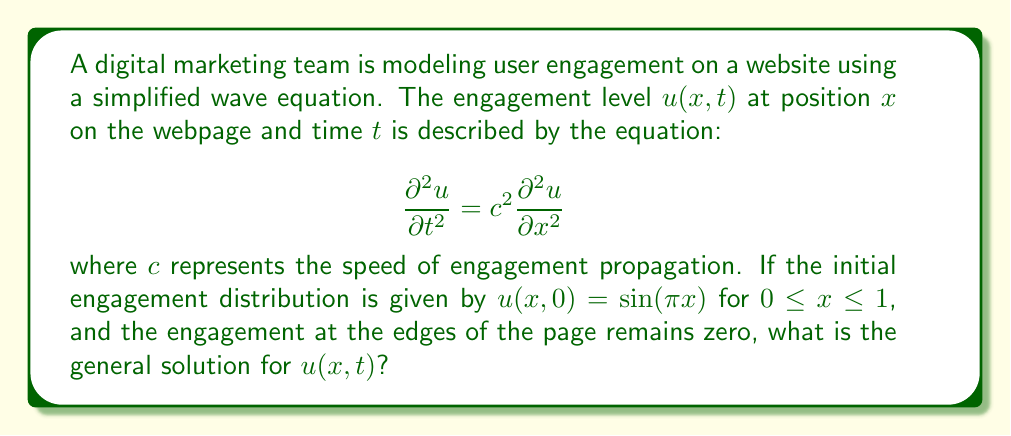What is the answer to this math problem? To solve this wave equation problem, we'll follow these steps:

1) The general solution for a wave equation with fixed endpoints (Dirichlet boundary conditions) is:

   $$u(x,t) = \sum_{n=1}^{\infty} (A_n \cos(n\pi ct) + B_n \sin(n\pi ct)) \sin(n\pi x)$$

2) Given the initial condition $u(x,0) = \sin(\pi x)$, we can determine that only the first term of the series (n=1) will be non-zero, and $A_1 = 1$, while all other $A_n$ and $B_n$ are zero.

3) We also need to consider the initial velocity. Since it's not specified, we can assume it's zero: $\frac{\partial u}{\partial t}(x,0) = 0$. This implies that $B_1 = 0$.

4) Substituting these values into the general solution:

   $$u(x,t) = \cos(\pi ct) \sin(\pi x)$$

This solution represents a standing wave, where the engagement level oscillates in place with a frequency determined by the propagation speed $c$.
Answer: $u(x,t) = \cos(\pi ct) \sin(\pi x)$ 